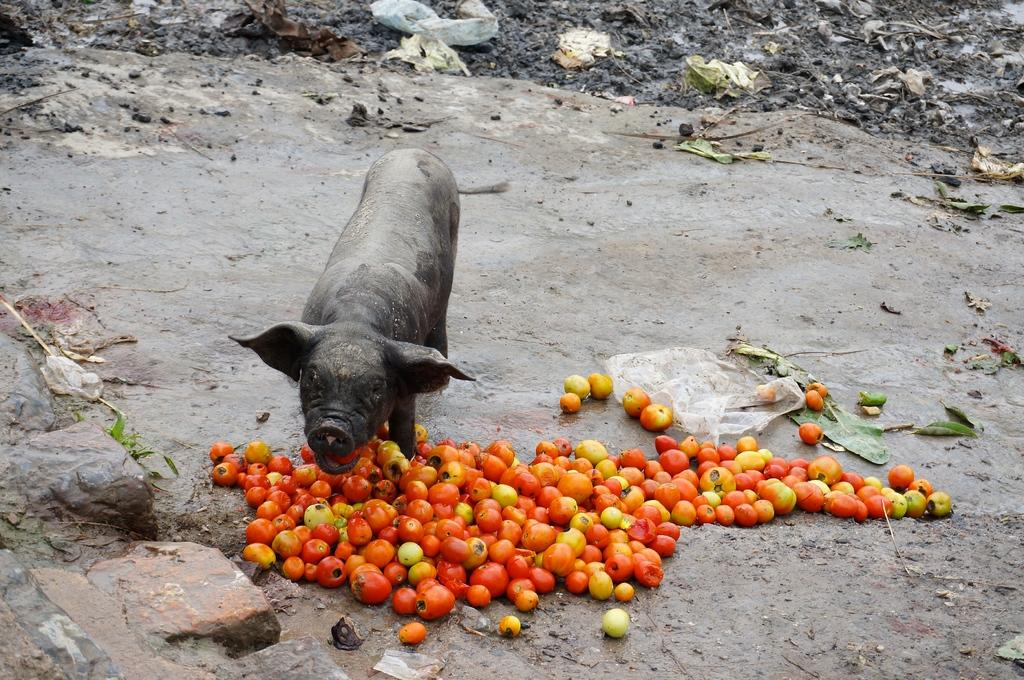What type of location is depicted in the image? The image is an outside view of a landfill. What can be found on the ground in the image? There are tomatoes and a pig on the ground. What is present at the top of the image? There is garbage material at the top of the image. How many spiders are crawling on the pen in the image? There is no pen or spiders present in the image. What type of bat is flying in the image? There is no bat present in the image. 